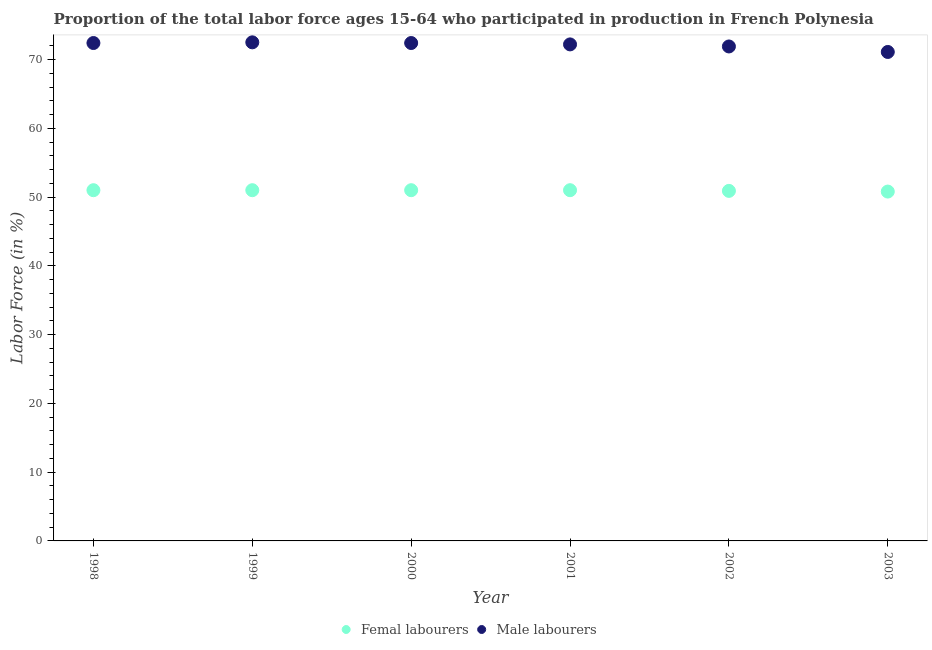What is the percentage of female labor force in 2001?
Make the answer very short. 51. Across all years, what is the minimum percentage of male labour force?
Offer a terse response. 71.1. In which year was the percentage of female labor force maximum?
Provide a short and direct response. 1998. In which year was the percentage of female labor force minimum?
Provide a short and direct response. 2003. What is the total percentage of male labour force in the graph?
Keep it short and to the point. 432.5. What is the difference between the percentage of male labour force in 1998 and that in 2000?
Make the answer very short. 0. What is the difference between the percentage of female labor force in 2002 and the percentage of male labour force in 1998?
Provide a short and direct response. -21.5. What is the average percentage of female labor force per year?
Ensure brevity in your answer.  50.95. In the year 2003, what is the difference between the percentage of male labour force and percentage of female labor force?
Offer a terse response. 20.3. What is the ratio of the percentage of female labor force in 2000 to that in 2003?
Your answer should be compact. 1. Is the percentage of female labor force in 1998 less than that in 2002?
Keep it short and to the point. No. Is the difference between the percentage of female labor force in 1998 and 2002 greater than the difference between the percentage of male labour force in 1998 and 2002?
Ensure brevity in your answer.  No. What is the difference between the highest and the second highest percentage of male labour force?
Give a very brief answer. 0.1. What is the difference between the highest and the lowest percentage of male labour force?
Offer a very short reply. 1.4. Is the sum of the percentage of male labour force in 1999 and 2002 greater than the maximum percentage of female labor force across all years?
Your response must be concise. Yes. Is the percentage of female labor force strictly less than the percentage of male labour force over the years?
Your answer should be compact. Yes. What is the difference between two consecutive major ticks on the Y-axis?
Offer a very short reply. 10. Are the values on the major ticks of Y-axis written in scientific E-notation?
Give a very brief answer. No. Does the graph contain any zero values?
Your answer should be very brief. No. How many legend labels are there?
Provide a succinct answer. 2. How are the legend labels stacked?
Keep it short and to the point. Horizontal. What is the title of the graph?
Provide a short and direct response. Proportion of the total labor force ages 15-64 who participated in production in French Polynesia. Does "Non-residents" appear as one of the legend labels in the graph?
Offer a very short reply. No. What is the Labor Force (in %) in Femal labourers in 1998?
Offer a terse response. 51. What is the Labor Force (in %) of Male labourers in 1998?
Keep it short and to the point. 72.4. What is the Labor Force (in %) of Male labourers in 1999?
Provide a short and direct response. 72.5. What is the Labor Force (in %) of Male labourers in 2000?
Your answer should be compact. 72.4. What is the Labor Force (in %) in Male labourers in 2001?
Keep it short and to the point. 72.2. What is the Labor Force (in %) of Femal labourers in 2002?
Give a very brief answer. 50.9. What is the Labor Force (in %) of Male labourers in 2002?
Your response must be concise. 71.9. What is the Labor Force (in %) in Femal labourers in 2003?
Offer a very short reply. 50.8. What is the Labor Force (in %) of Male labourers in 2003?
Your response must be concise. 71.1. Across all years, what is the maximum Labor Force (in %) in Male labourers?
Keep it short and to the point. 72.5. Across all years, what is the minimum Labor Force (in %) in Femal labourers?
Provide a succinct answer. 50.8. Across all years, what is the minimum Labor Force (in %) of Male labourers?
Your response must be concise. 71.1. What is the total Labor Force (in %) of Femal labourers in the graph?
Your answer should be very brief. 305.7. What is the total Labor Force (in %) in Male labourers in the graph?
Your answer should be compact. 432.5. What is the difference between the Labor Force (in %) in Femal labourers in 1998 and that in 1999?
Provide a short and direct response. 0. What is the difference between the Labor Force (in %) of Femal labourers in 1998 and that in 2000?
Offer a terse response. 0. What is the difference between the Labor Force (in %) of Male labourers in 1998 and that in 2000?
Your response must be concise. 0. What is the difference between the Labor Force (in %) in Femal labourers in 1998 and that in 2001?
Offer a very short reply. 0. What is the difference between the Labor Force (in %) in Male labourers in 1998 and that in 2002?
Make the answer very short. 0.5. What is the difference between the Labor Force (in %) of Femal labourers in 1998 and that in 2003?
Keep it short and to the point. 0.2. What is the difference between the Labor Force (in %) in Male labourers in 1998 and that in 2003?
Your response must be concise. 1.3. What is the difference between the Labor Force (in %) in Femal labourers in 1999 and that in 2000?
Offer a terse response. 0. What is the difference between the Labor Force (in %) of Male labourers in 1999 and that in 2000?
Make the answer very short. 0.1. What is the difference between the Labor Force (in %) in Femal labourers in 1999 and that in 2002?
Offer a terse response. 0.1. What is the difference between the Labor Force (in %) of Male labourers in 1999 and that in 2003?
Offer a very short reply. 1.4. What is the difference between the Labor Force (in %) in Femal labourers in 2000 and that in 2001?
Offer a terse response. 0. What is the difference between the Labor Force (in %) in Male labourers in 2000 and that in 2001?
Your response must be concise. 0.2. What is the difference between the Labor Force (in %) in Femal labourers in 2001 and that in 2003?
Offer a terse response. 0.2. What is the difference between the Labor Force (in %) of Femal labourers in 1998 and the Labor Force (in %) of Male labourers in 1999?
Make the answer very short. -21.5. What is the difference between the Labor Force (in %) of Femal labourers in 1998 and the Labor Force (in %) of Male labourers in 2000?
Provide a short and direct response. -21.4. What is the difference between the Labor Force (in %) of Femal labourers in 1998 and the Labor Force (in %) of Male labourers in 2001?
Ensure brevity in your answer.  -21.2. What is the difference between the Labor Force (in %) in Femal labourers in 1998 and the Labor Force (in %) in Male labourers in 2002?
Give a very brief answer. -20.9. What is the difference between the Labor Force (in %) of Femal labourers in 1998 and the Labor Force (in %) of Male labourers in 2003?
Your answer should be compact. -20.1. What is the difference between the Labor Force (in %) of Femal labourers in 1999 and the Labor Force (in %) of Male labourers in 2000?
Your answer should be compact. -21.4. What is the difference between the Labor Force (in %) in Femal labourers in 1999 and the Labor Force (in %) in Male labourers in 2001?
Provide a succinct answer. -21.2. What is the difference between the Labor Force (in %) in Femal labourers in 1999 and the Labor Force (in %) in Male labourers in 2002?
Provide a succinct answer. -20.9. What is the difference between the Labor Force (in %) in Femal labourers in 1999 and the Labor Force (in %) in Male labourers in 2003?
Offer a very short reply. -20.1. What is the difference between the Labor Force (in %) of Femal labourers in 2000 and the Labor Force (in %) of Male labourers in 2001?
Ensure brevity in your answer.  -21.2. What is the difference between the Labor Force (in %) of Femal labourers in 2000 and the Labor Force (in %) of Male labourers in 2002?
Offer a terse response. -20.9. What is the difference between the Labor Force (in %) in Femal labourers in 2000 and the Labor Force (in %) in Male labourers in 2003?
Your response must be concise. -20.1. What is the difference between the Labor Force (in %) in Femal labourers in 2001 and the Labor Force (in %) in Male labourers in 2002?
Keep it short and to the point. -20.9. What is the difference between the Labor Force (in %) in Femal labourers in 2001 and the Labor Force (in %) in Male labourers in 2003?
Offer a terse response. -20.1. What is the difference between the Labor Force (in %) in Femal labourers in 2002 and the Labor Force (in %) in Male labourers in 2003?
Provide a succinct answer. -20.2. What is the average Labor Force (in %) in Femal labourers per year?
Provide a succinct answer. 50.95. What is the average Labor Force (in %) of Male labourers per year?
Your answer should be compact. 72.08. In the year 1998, what is the difference between the Labor Force (in %) of Femal labourers and Labor Force (in %) of Male labourers?
Your answer should be very brief. -21.4. In the year 1999, what is the difference between the Labor Force (in %) of Femal labourers and Labor Force (in %) of Male labourers?
Your response must be concise. -21.5. In the year 2000, what is the difference between the Labor Force (in %) of Femal labourers and Labor Force (in %) of Male labourers?
Your answer should be compact. -21.4. In the year 2001, what is the difference between the Labor Force (in %) in Femal labourers and Labor Force (in %) in Male labourers?
Offer a terse response. -21.2. In the year 2003, what is the difference between the Labor Force (in %) of Femal labourers and Labor Force (in %) of Male labourers?
Your answer should be very brief. -20.3. What is the ratio of the Labor Force (in %) of Male labourers in 1998 to that in 1999?
Give a very brief answer. 1. What is the ratio of the Labor Force (in %) of Femal labourers in 1998 to that in 2002?
Your answer should be compact. 1. What is the ratio of the Labor Force (in %) in Male labourers in 1998 to that in 2002?
Provide a succinct answer. 1.01. What is the ratio of the Labor Force (in %) in Male labourers in 1998 to that in 2003?
Your response must be concise. 1.02. What is the ratio of the Labor Force (in %) of Femal labourers in 1999 to that in 2000?
Give a very brief answer. 1. What is the ratio of the Labor Force (in %) in Femal labourers in 1999 to that in 2001?
Your answer should be very brief. 1. What is the ratio of the Labor Force (in %) in Femal labourers in 1999 to that in 2002?
Your answer should be compact. 1. What is the ratio of the Labor Force (in %) of Male labourers in 1999 to that in 2002?
Keep it short and to the point. 1.01. What is the ratio of the Labor Force (in %) in Male labourers in 1999 to that in 2003?
Offer a very short reply. 1.02. What is the ratio of the Labor Force (in %) in Male labourers in 2000 to that in 2001?
Your response must be concise. 1. What is the ratio of the Labor Force (in %) of Male labourers in 2000 to that in 2002?
Provide a succinct answer. 1.01. What is the ratio of the Labor Force (in %) in Male labourers in 2000 to that in 2003?
Offer a very short reply. 1.02. What is the ratio of the Labor Force (in %) in Femal labourers in 2001 to that in 2002?
Your answer should be very brief. 1. What is the ratio of the Labor Force (in %) in Male labourers in 2001 to that in 2002?
Give a very brief answer. 1. What is the ratio of the Labor Force (in %) of Male labourers in 2001 to that in 2003?
Your answer should be very brief. 1.02. What is the ratio of the Labor Force (in %) in Male labourers in 2002 to that in 2003?
Your response must be concise. 1.01. What is the difference between the highest and the second highest Labor Force (in %) of Femal labourers?
Offer a very short reply. 0. 